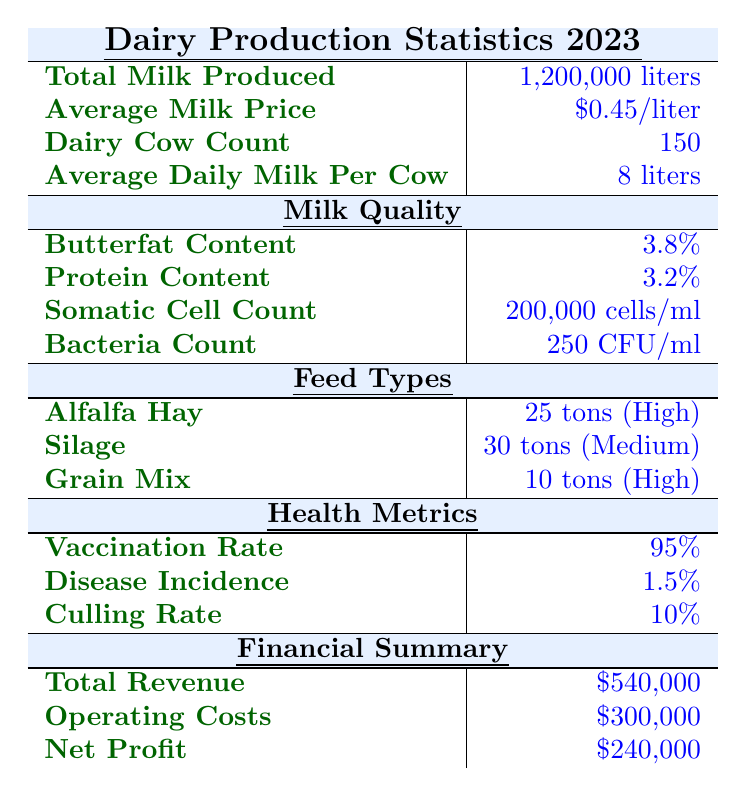What was the total milk produced in 2023? The data in the table states that the total milk produced in 2023 is 1,200,000 liters.
Answer: 1,200,000 liters What is the average milk price per liter? According to the table, the average milk price per liter is $0.45.
Answer: $0.45 How many dairy cows are counted in this year's statistics? The table indicates that there are 150 dairy cows counted in 2023.
Answer: 150 What is the average daily milk production per cow? The average daily milk production per cow, as per the table, is stated as 8 liters.
Answer: 8 liters What is the butterfat content of the milk? The table shows that the butterfat content of the milk is 3.8%.
Answer: 3.8% What is the vaccination rate among the dairy cows? According to the table, the vaccination rate is 95%.
Answer: 95% What was the total revenue generated from dairy production in 2023? The total revenue generated from dairy production in 2023, as per the table, is $540,000.
Answer: $540,000 If the operating costs are $300,000, what is the net profit? The table states the net profit as $240,000, which is calculated by subtracting operating costs ($300,000) from total revenue ($540,000). Therefore, Net Profit = $540,000 - $300,000 = $240,000.
Answer: $240,000 What is the total quantity of feed types used? The table lists tons used for each feed type: Alfalfa Hay (25 tons), Silage (30 tons), and Grain Mix (10 tons). The total quantity is 25 + 30 + 10 = 65 tons.
Answer: 65 tons Is the disease incidence rate above or below 2%? The table states that the disease incidence rate is 1.5%, which is below 2%. Therefore, the answer is no, it is not above 2%.
Answer: No What percentage of the dairy cows were vaccinated? The vaccination rate from the table shows that 95% of the dairy cows were vaccinated.
Answer: 95% Is the bacterial count within an acceptable range? The table lists the bacteria count as 250 CFU/ml. Generally, a count below 1,000 CFU/ml is considered acceptable, so this is within the acceptable range.
Answer: Yes How much more is the total revenue compared to operating costs? The total revenue is $540,000 and the operating costs are $300,000. The difference is calculated as $540,000 - $300,000 = $240,000.
Answer: $240,000 What is the average protein content in the milk? The table indicates that the average protein content in the milk is 3.2%.
Answer: 3.2% Calculate the average daily milk production for all dairy cows combined. To find the average daily milk production for all dairy cows, we multiply the average daily milk per cow (8 liters) by the total dairy cow count (150). This gives us 8 liters/cow * 150 cows = 1,200 liters/day.
Answer: 1,200 liters/day What nutritional value category does silage fall under? The table categorizes silage as having a medium nutritional value.
Answer: Medium 